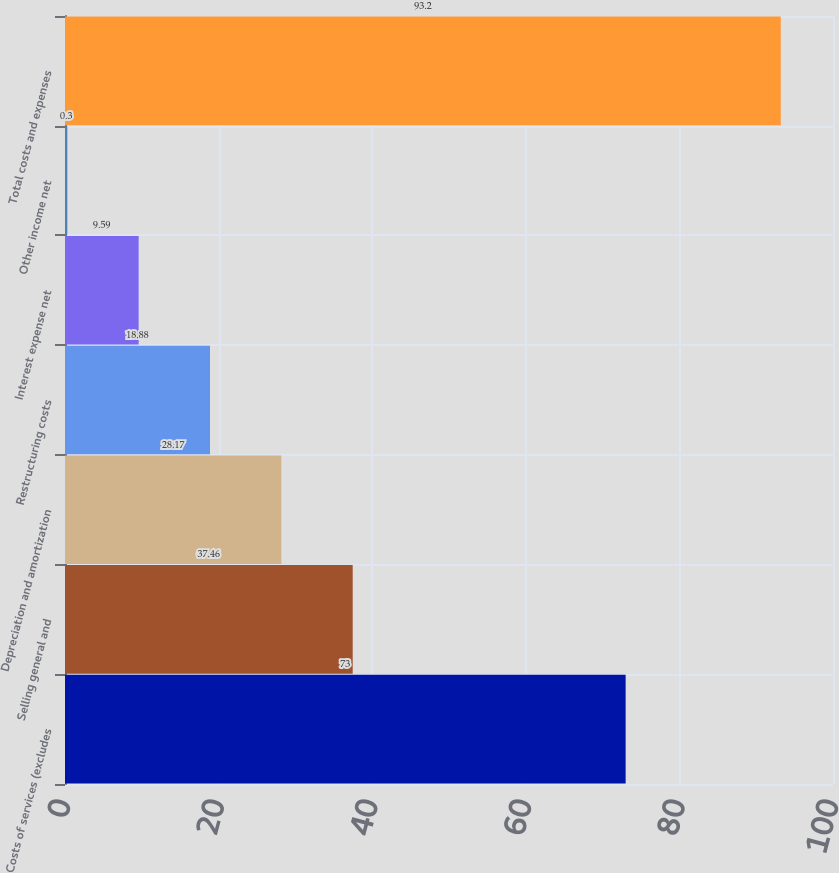<chart> <loc_0><loc_0><loc_500><loc_500><bar_chart><fcel>Costs of services (excludes<fcel>Selling general and<fcel>Depreciation and amortization<fcel>Restructuring costs<fcel>Interest expense net<fcel>Other income net<fcel>Total costs and expenses<nl><fcel>73<fcel>37.46<fcel>28.17<fcel>18.88<fcel>9.59<fcel>0.3<fcel>93.2<nl></chart> 